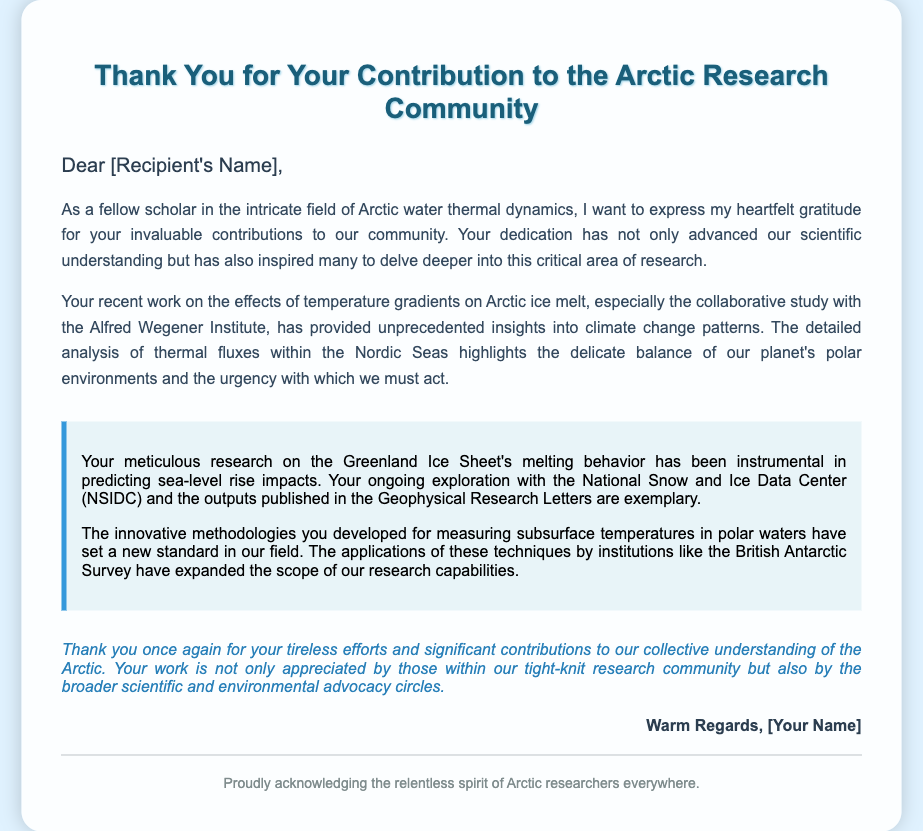What is the title of the card? The title of the card is prominently stated at the top of the document.
Answer: Thank You for Your Contribution to the Arctic Research Community Who is the card addressed to? The card uses a placeholder for the recipient's name in the greeting section.
Answer: [Recipient's Name] Which organization's study is mentioned in the document? The document specifically references a collaborative study with a prominent research institute.
Answer: Alfred Wegener Institute What environmental issue is highlighted in the card? The card discusses a specific consequence of climate change that is pertinent to the Arctic region.
Answer: Sea-level rise What are the Greenland Ice Sheet's melting behavior's impacts focusing on? The document identifies the focus of research regarding a key Arctic feature and its implications.
Answer: Predicting sea-level rise impacts Who authored the letter? The signature section includes a placeholder for the author's name, indicating the person who wrote the card.
Answer: [Your Name] What is the background of the card? The background of the greeting card is essential in setting the scene related to the theme of the card.
Answer: Glacial scene What methodology is mentioned in the closing statements? The document emphasizes innovative approaches that were developed for measuring a particular aspect in polar research.
Answer: Measuring subsurface temperatures Why is the recipient's work appreciated? The appreciation is primarily due to the impact and significance of their efforts within the scientific community.
Answer: Tireless efforts and significant contributions 